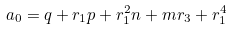<formula> <loc_0><loc_0><loc_500><loc_500>a _ { 0 } = q + r _ { 1 } p + r _ { 1 } ^ { 2 } n + m r _ { 3 } + r _ { 1 } ^ { 4 }</formula> 